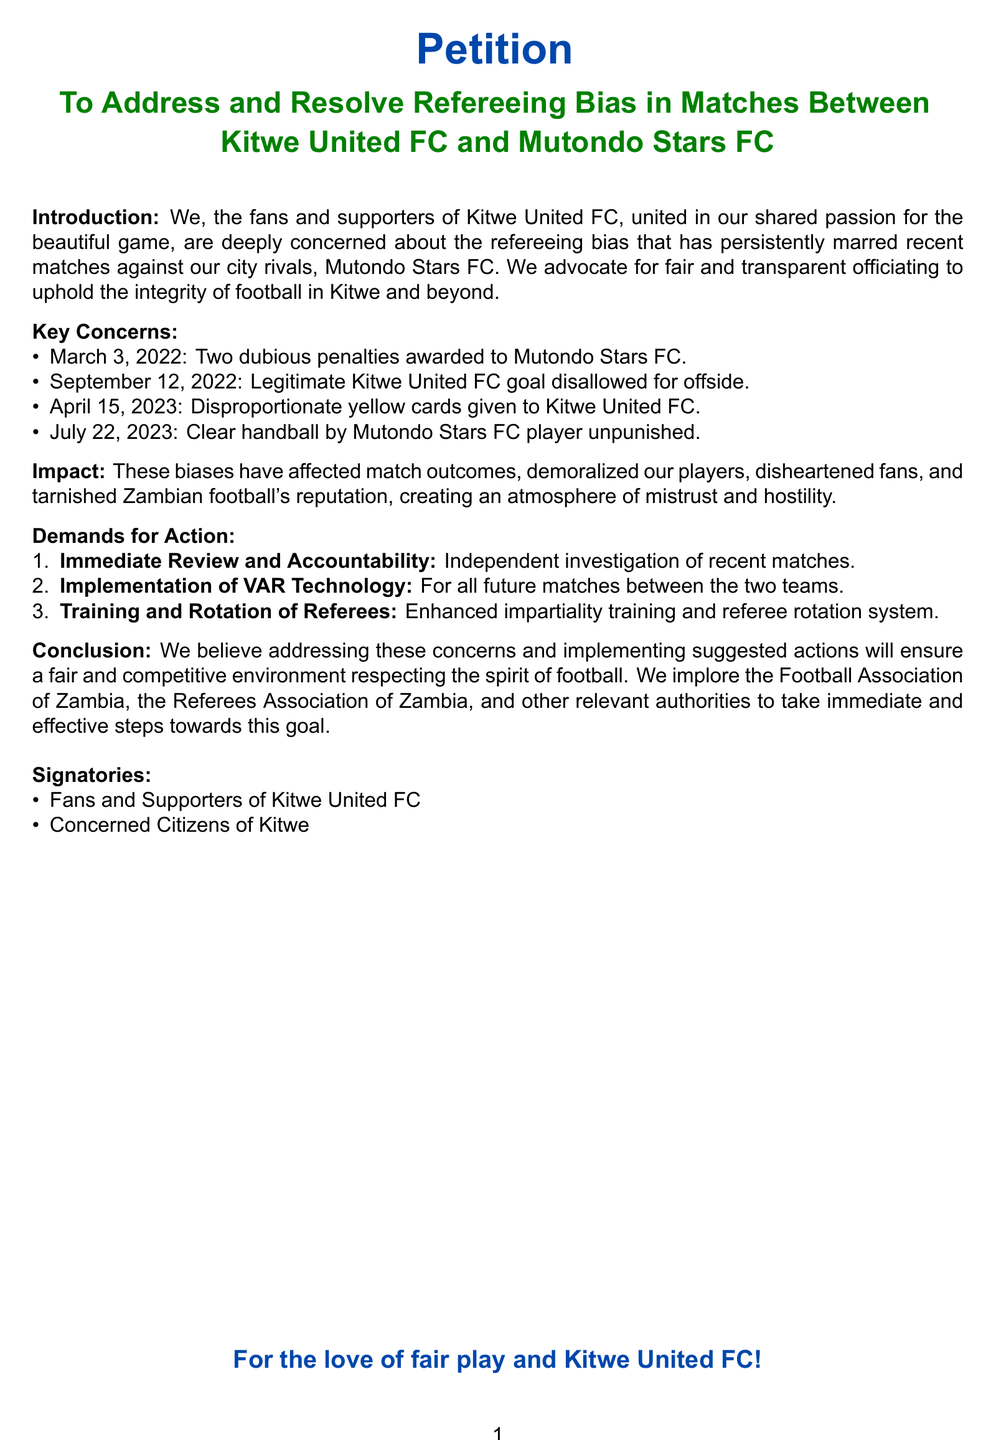what is the main purpose of the petition? The main purpose of the petition is to address and resolve refereeing bias in matches between Kitwe United FC and Mutondo Stars FC.
Answer: to address and resolve refereeing bias who are the signatories of the petition? The signatories of the petition include fans and supporters of Kitwe United FC and concerned citizens of Kitwe.
Answer: Fans and Supporters of Kitwe United FC, Concerned Citizens of Kitwe how many key concerns are listed in the petition? There are four key concerns listed in the petition regarding officiating in matches.
Answer: four which technology is demanded for implementation in future matches? The petition demands the implementation of VAR technology for all future matches between the two teams.
Answer: VAR technology what happened on September 12, 2022, in the context of the document? A legitimate Kitwe United FC goal was disallowed for offside on this date.
Answer: Legitimate Kitwe United FC goal disallowed for offside what is the first demand for action presented in the petition? The first demand for action is an immediate review and accountability through an independent investigation of recent matches.
Answer: Immediate Review and Accountability how many incidents of alleged bias are mentioned in the document? There are four specific incidents of alleged bias mentioned in the document.
Answer: four which colors represent Kitwe United FC in the document? The colors representing Kitwe United FC in the document are blue and green.
Answer: blue and green what does the conclusion implore the authorities to do? The conclusion implores the authorities to take immediate and effective steps towards ensuring fair and competitive football.
Answer: immediate and effective steps 